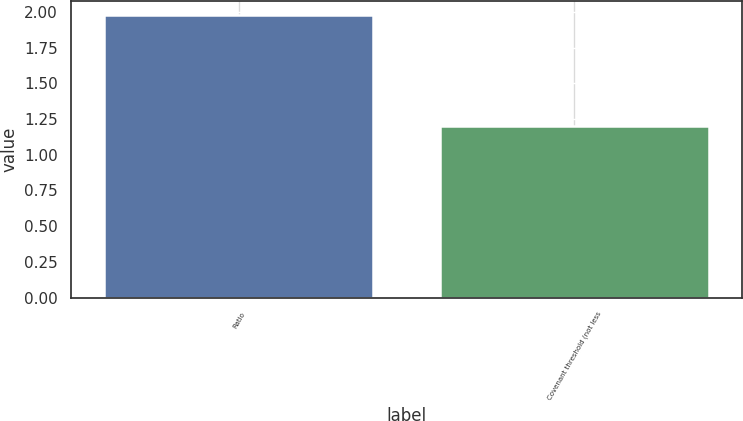Convert chart to OTSL. <chart><loc_0><loc_0><loc_500><loc_500><bar_chart><fcel>Ratio<fcel>Covenant threshold (not less<nl><fcel>1.98<fcel>1.2<nl></chart> 